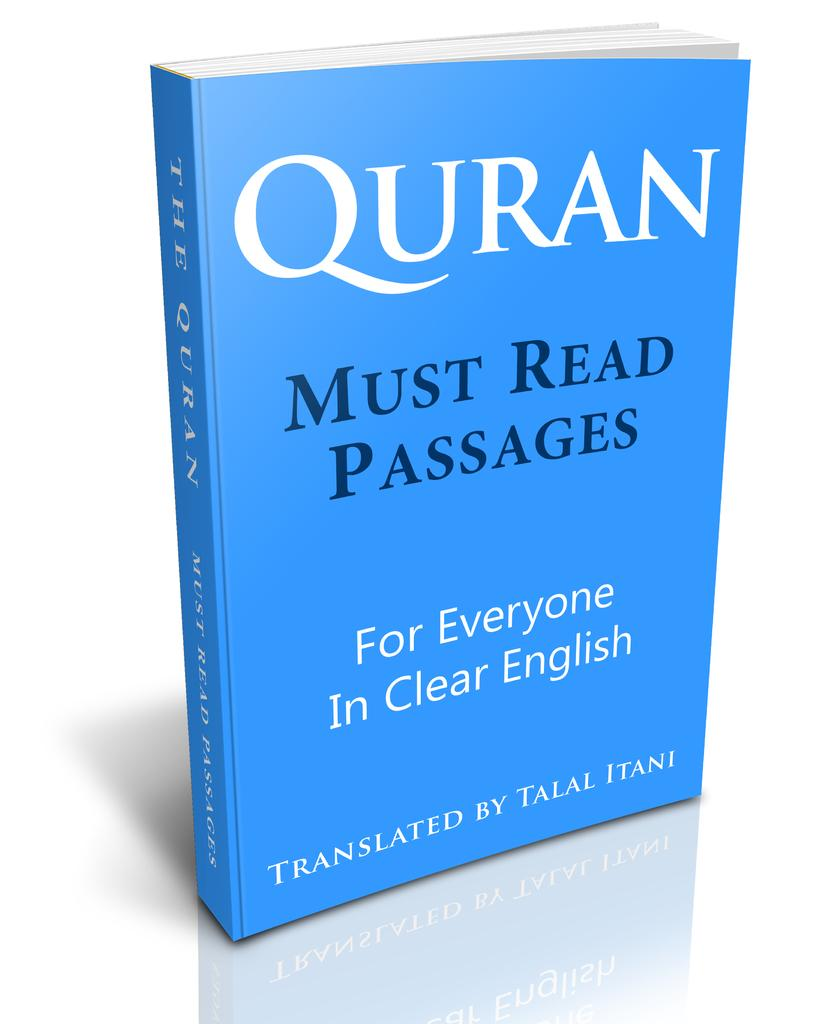<image>
Render a clear and concise summary of the photo. blue copy of quran in english standing upright against white background 